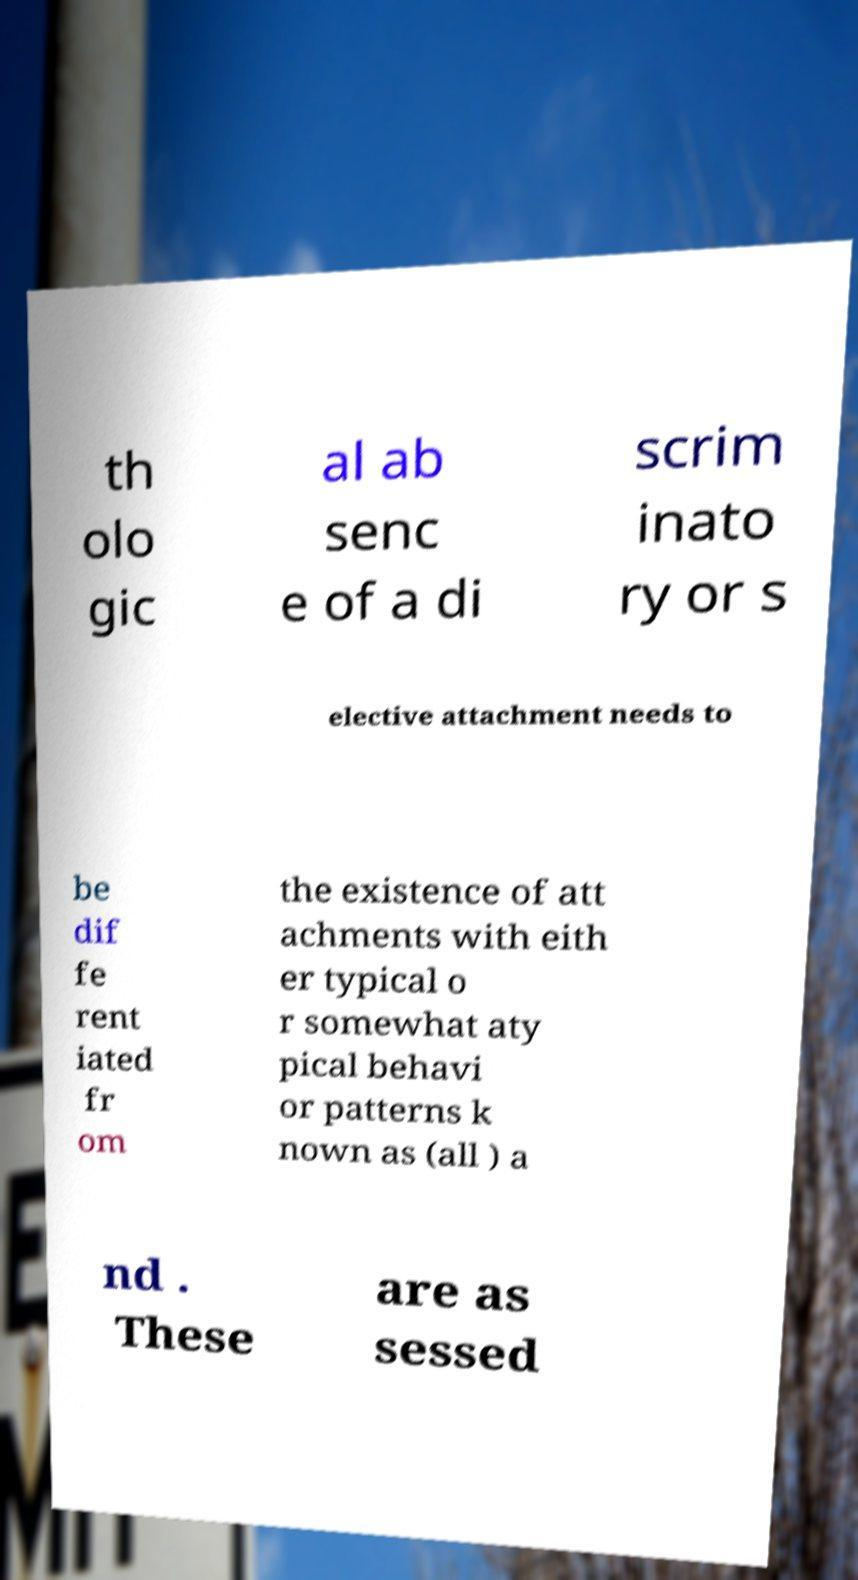Can you accurately transcribe the text from the provided image for me? th olo gic al ab senc e of a di scrim inato ry or s elective attachment needs to be dif fe rent iated fr om the existence of att achments with eith er typical o r somewhat aty pical behavi or patterns k nown as (all ) a nd . These are as sessed 